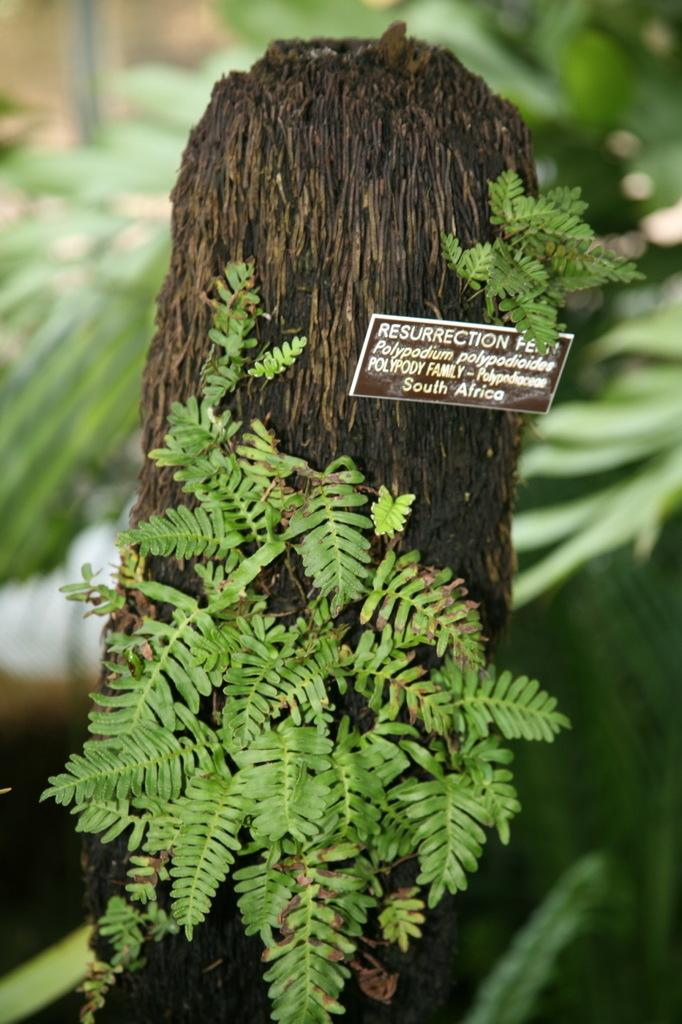What type of living organisms can be seen in the image? Plants can be seen in the image. What color are the plants in the image? The plants are green. What object is visible in the image that is typically used for carrying or storing items? There is a trunk visible in the image. What is the color of the board in the image? The board in the image is black. What can be seen in the background of the image? Trees and plants can be seen in the background of the image. How many loaves of bread can be seen in the image? There are no loaves of bread present in the image. What type of geese are depicted in the image? There are no geese depicted in the image. 